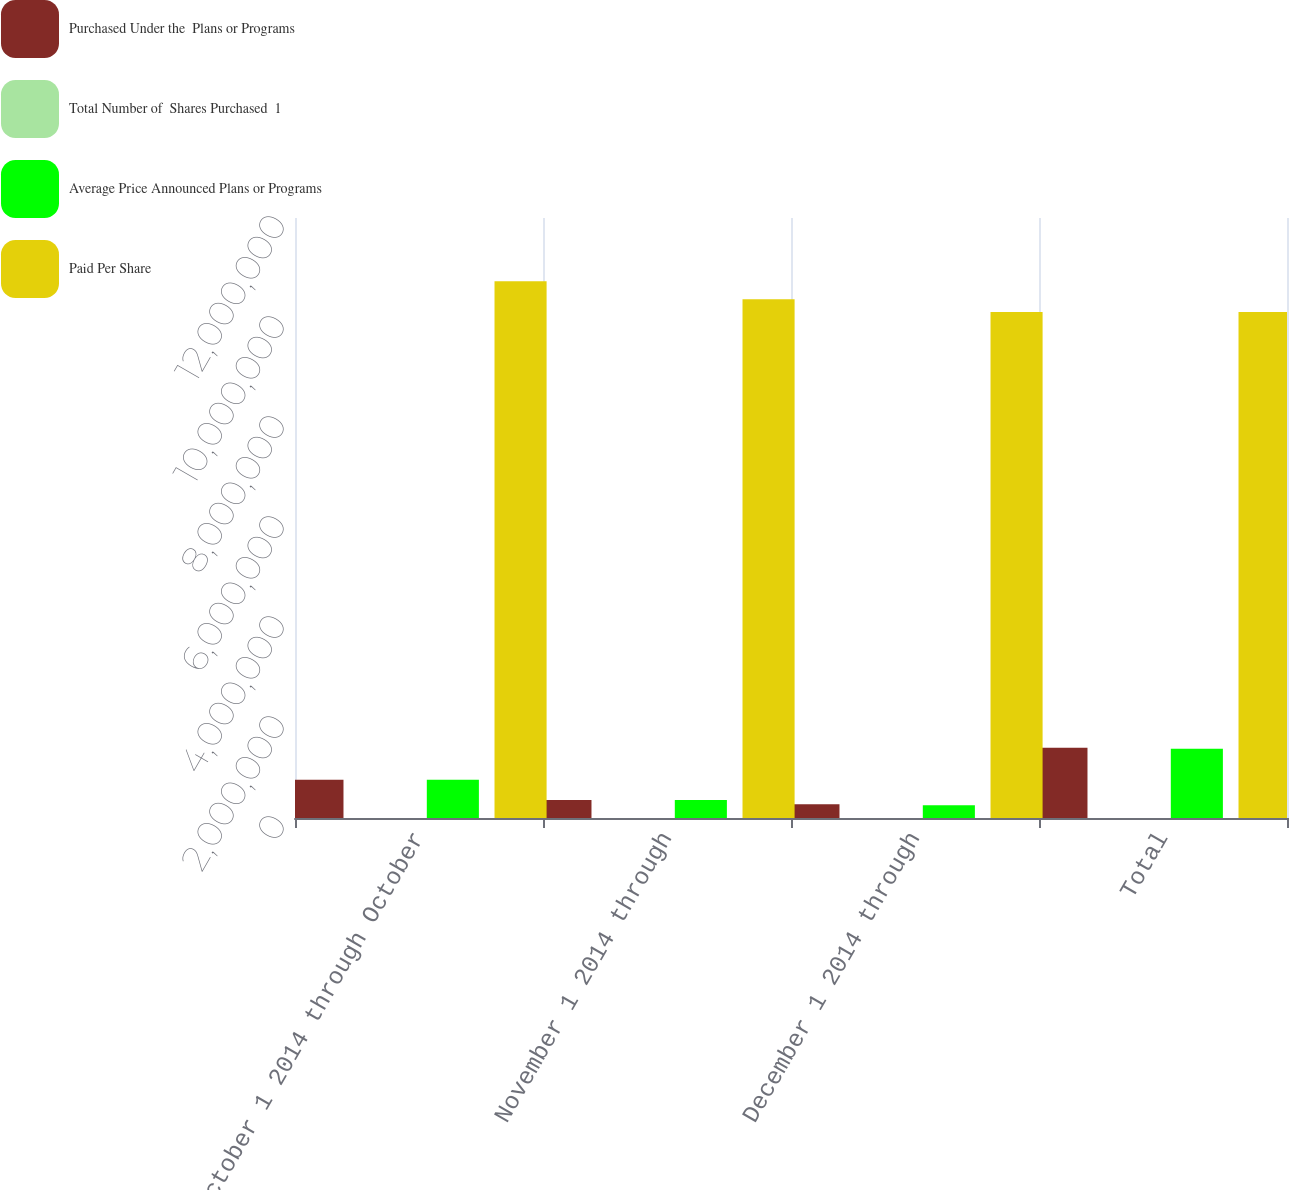Convert chart to OTSL. <chart><loc_0><loc_0><loc_500><loc_500><stacked_bar_chart><ecel><fcel>October 1 2014 through October<fcel>November 1 2014 through<fcel>December 1 2014 through<fcel>Total<nl><fcel>Purchased Under the  Plans or Programs<fcel>763915<fcel>362283<fcel>277231<fcel>1.40343e+06<nl><fcel>Total Number of  Shares Purchased  1<fcel>33.33<fcel>38.64<fcel>41.36<fcel>36.17<nl><fcel>Average Price Announced Plans or Programs<fcel>763915<fcel>362283<fcel>256490<fcel>1.38269e+06<nl><fcel>Paid Per Share<fcel>1.07375e+07<fcel>1.03752e+07<fcel>1.01187e+07<fcel>1.01187e+07<nl></chart> 